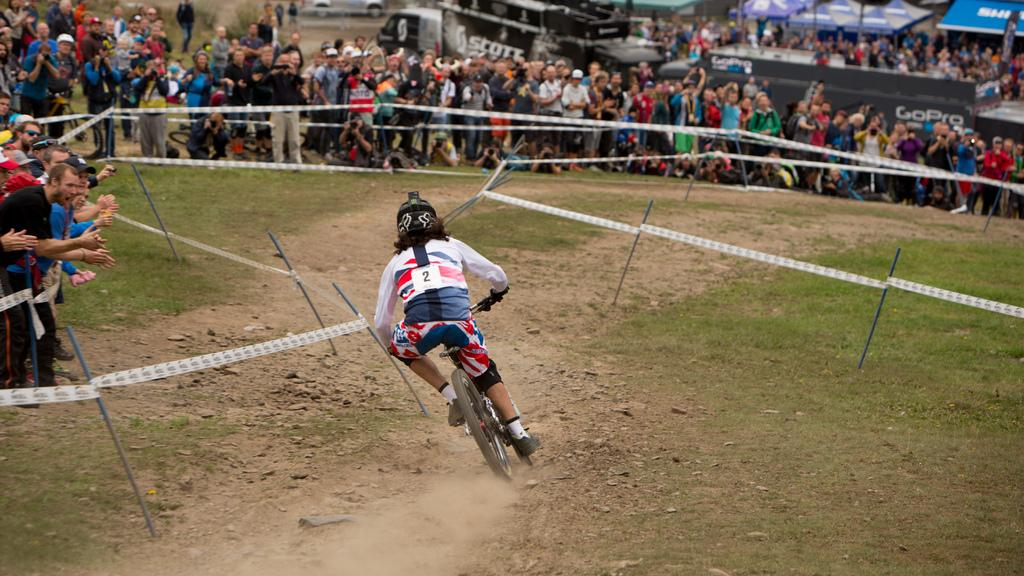Provide a one-sentence caption for the provided image. A man wearing the number 1 bikes across a course as people watch and cheer him on. 